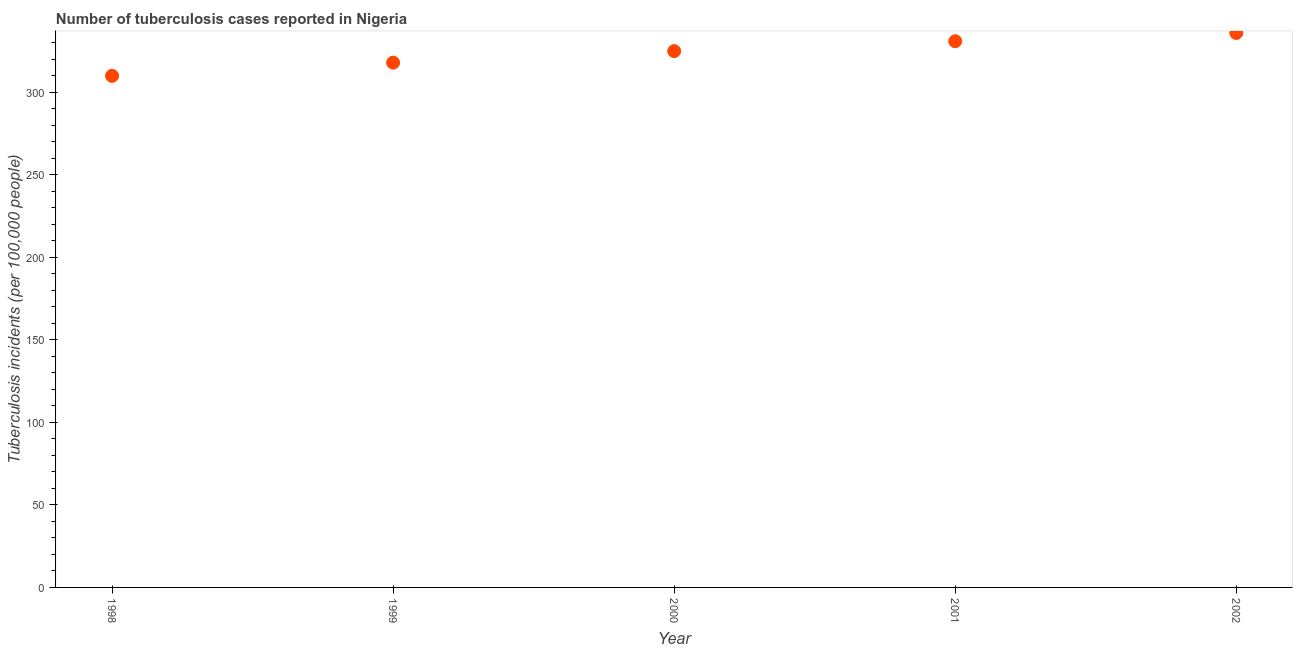What is the number of tuberculosis incidents in 1998?
Give a very brief answer. 310. Across all years, what is the maximum number of tuberculosis incidents?
Your answer should be compact. 336. Across all years, what is the minimum number of tuberculosis incidents?
Your response must be concise. 310. What is the sum of the number of tuberculosis incidents?
Your answer should be compact. 1620. What is the difference between the number of tuberculosis incidents in 1999 and 2002?
Ensure brevity in your answer.  -18. What is the average number of tuberculosis incidents per year?
Your answer should be compact. 324. What is the median number of tuberculosis incidents?
Give a very brief answer. 325. In how many years, is the number of tuberculosis incidents greater than 80 ?
Give a very brief answer. 5. What is the ratio of the number of tuberculosis incidents in 1999 to that in 2001?
Offer a very short reply. 0.96. Is the difference between the number of tuberculosis incidents in 1999 and 2002 greater than the difference between any two years?
Your answer should be very brief. No. What is the difference between the highest and the lowest number of tuberculosis incidents?
Make the answer very short. 26. How many years are there in the graph?
Make the answer very short. 5. What is the difference between two consecutive major ticks on the Y-axis?
Give a very brief answer. 50. Does the graph contain any zero values?
Keep it short and to the point. No. What is the title of the graph?
Make the answer very short. Number of tuberculosis cases reported in Nigeria. What is the label or title of the Y-axis?
Your answer should be very brief. Tuberculosis incidents (per 100,0 people). What is the Tuberculosis incidents (per 100,000 people) in 1998?
Provide a short and direct response. 310. What is the Tuberculosis incidents (per 100,000 people) in 1999?
Keep it short and to the point. 318. What is the Tuberculosis incidents (per 100,000 people) in 2000?
Provide a succinct answer. 325. What is the Tuberculosis incidents (per 100,000 people) in 2001?
Offer a terse response. 331. What is the Tuberculosis incidents (per 100,000 people) in 2002?
Keep it short and to the point. 336. What is the difference between the Tuberculosis incidents (per 100,000 people) in 1998 and 2000?
Give a very brief answer. -15. What is the difference between the Tuberculosis incidents (per 100,000 people) in 1999 and 2001?
Your answer should be very brief. -13. What is the difference between the Tuberculosis incidents (per 100,000 people) in 1999 and 2002?
Give a very brief answer. -18. What is the difference between the Tuberculosis incidents (per 100,000 people) in 2000 and 2001?
Your response must be concise. -6. What is the difference between the Tuberculosis incidents (per 100,000 people) in 2000 and 2002?
Provide a short and direct response. -11. What is the difference between the Tuberculosis incidents (per 100,000 people) in 2001 and 2002?
Keep it short and to the point. -5. What is the ratio of the Tuberculosis incidents (per 100,000 people) in 1998 to that in 2000?
Your response must be concise. 0.95. What is the ratio of the Tuberculosis incidents (per 100,000 people) in 1998 to that in 2001?
Ensure brevity in your answer.  0.94. What is the ratio of the Tuberculosis incidents (per 100,000 people) in 1998 to that in 2002?
Make the answer very short. 0.92. What is the ratio of the Tuberculosis incidents (per 100,000 people) in 1999 to that in 2002?
Provide a short and direct response. 0.95. What is the ratio of the Tuberculosis incidents (per 100,000 people) in 2000 to that in 2001?
Give a very brief answer. 0.98. What is the ratio of the Tuberculosis incidents (per 100,000 people) in 2001 to that in 2002?
Your answer should be compact. 0.98. 